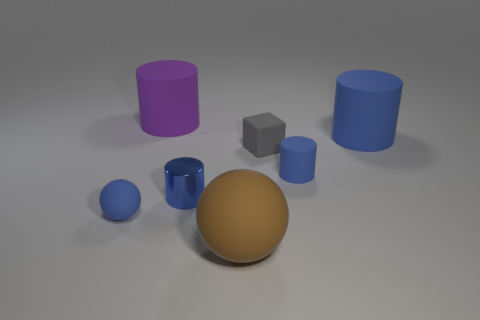How many blue cylinders must be subtracted to get 1 blue cylinders? 2 Subtract all shiny cylinders. How many cylinders are left? 3 Subtract all red cubes. How many blue cylinders are left? 3 Add 2 big blue matte things. How many objects exist? 9 Subtract all purple cylinders. How many cylinders are left? 3 Subtract 1 cylinders. How many cylinders are left? 3 Subtract all cyan cylinders. Subtract all green balls. How many cylinders are left? 4 Subtract all cylinders. How many objects are left? 3 Subtract 0 yellow cylinders. How many objects are left? 7 Subtract all green metallic objects. Subtract all tiny rubber blocks. How many objects are left? 6 